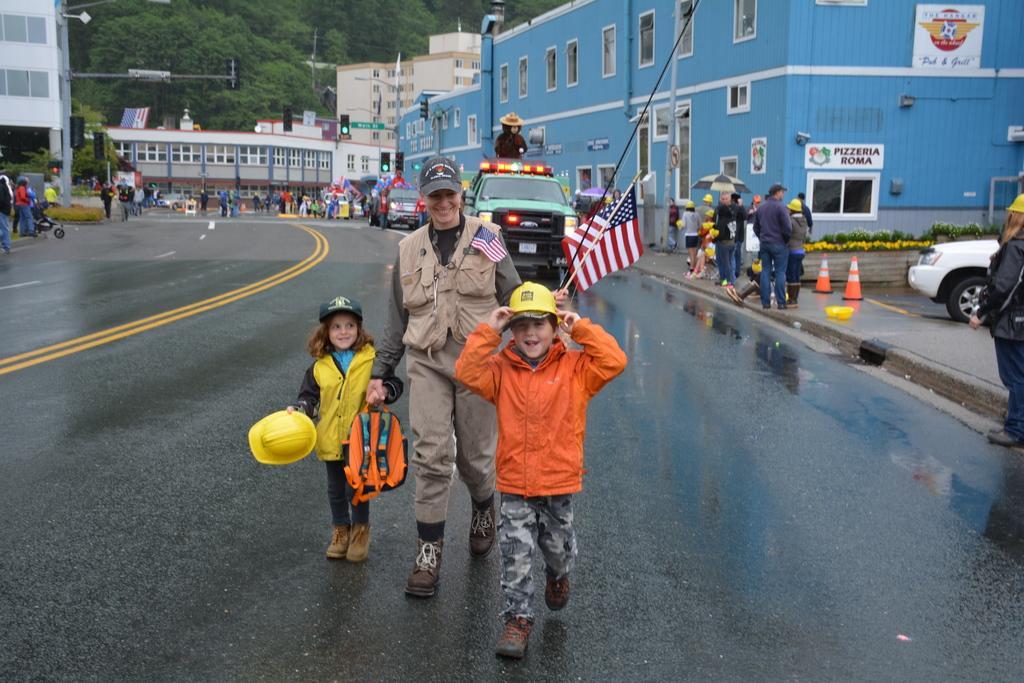Could you give a brief overview of what you see in this image? In this image we can see a few people, among them some are wearing the yellow color helmets and we can see a kid holding a flag, there are some vehicles, buildings with windows, poles, lights and other objects, in the background we can see the trees. 